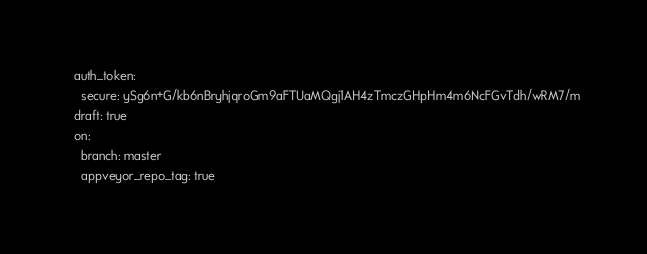Convert code to text. <code><loc_0><loc_0><loc_500><loc_500><_YAML_>  auth_token:
    secure: ySg6n+G/kb6nBryhjqroGm9aFTUaMQgj1AH4zTmczGHpHm4m6NcFGvTdh/wRM7/m
  draft: true
  on:
    branch: master
    appveyor_repo_tag: true
</code> 